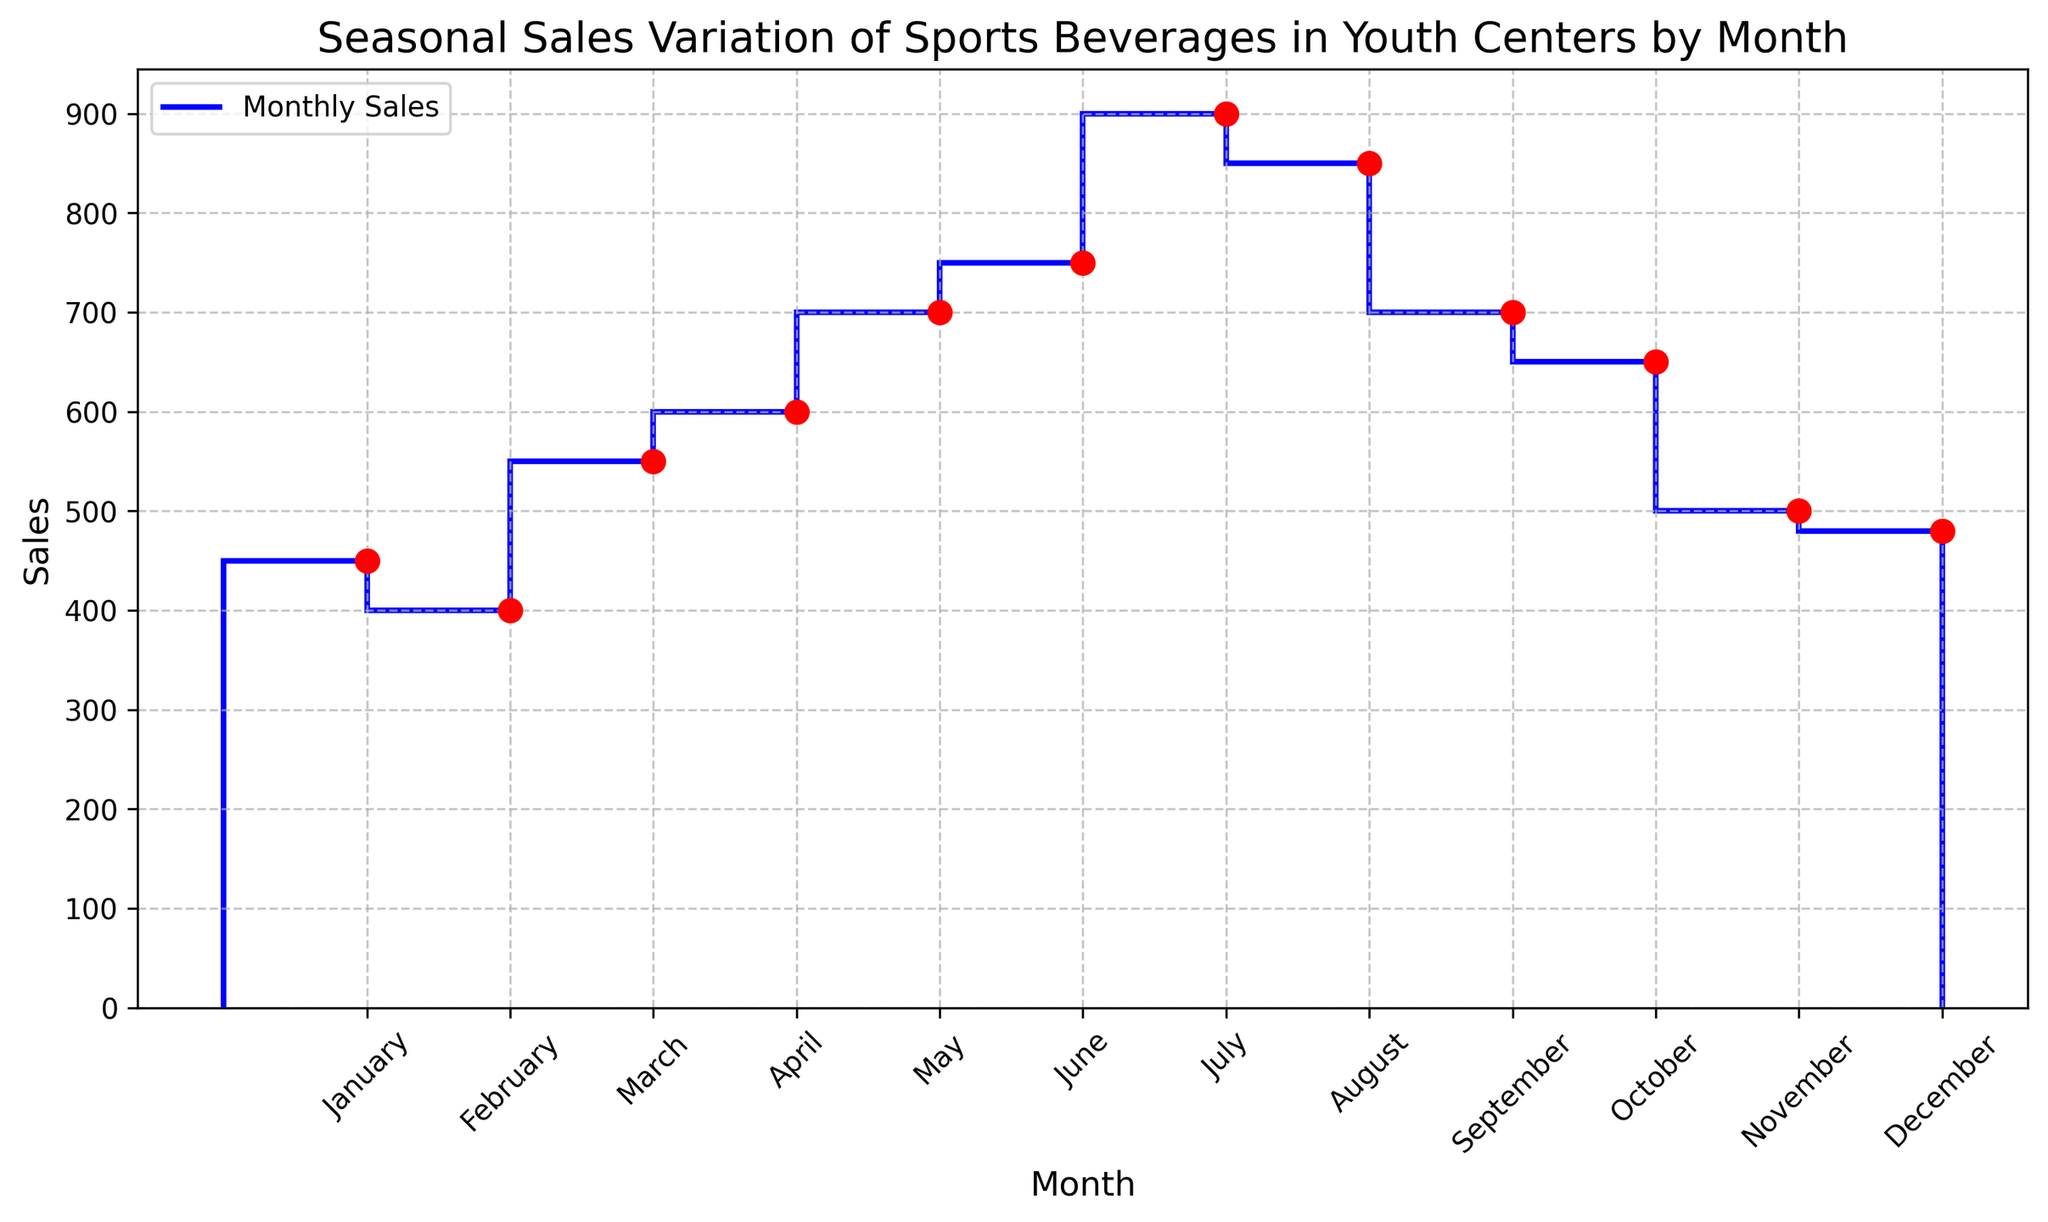Which month had the highest sales? The highest point on the stairs plot indicates the highest sales, which occurs in July with a value of 900.
Answer: July How much did sales increase from February to March? Look at the sales in February (400) and March (550). Subtracting February's sales from March's sales gives 550 - 400 = 150.
Answer: 150 Which month had lower sales: April or October? Compare the sales heights for April (600) and October (650). April’s sales are lower.
Answer: April What is the total sales for the months of May through August? Sum the sales from May (700), June (750), July (900), and August (850). So, 700 + 750 + 900 + 850 = 3200.
Answer: 3200 How do the sales in June compare to December? Compare the sales for June (750) and December (480). June's sales are higher.
Answer: June What is the sales difference between the highest and the lowest sales months? Identify the highest sales in July (900) and the lowest in February (400). Subtract the lowest from the highest: 900 - 400 = 500.
Answer: 500 How did the sales change from January to December? Compare the sales in January (450) and December (480). There is a slight increase in sales: 480 - 450 = 30.
Answer: Increased by 30 Which months had sales equal to or exceeding 700? Look at the plot and identify months with sales bars equal to or above 700: May (700), June (750), July (900), August (850), and September (700).
Answer: May, June, July, August, September What is the average sales from January to June? Calculate the average of the sales from January to June: (450 + 400 + 550 + 600 + 700 + 750)/6 = 4050/6 = 675.
Answer: 675 What is the sales trend from July to September? Observe the plot from July (900) to August (850) to September (700). Sales are decreasing over these months.
Answer: Decreasing 